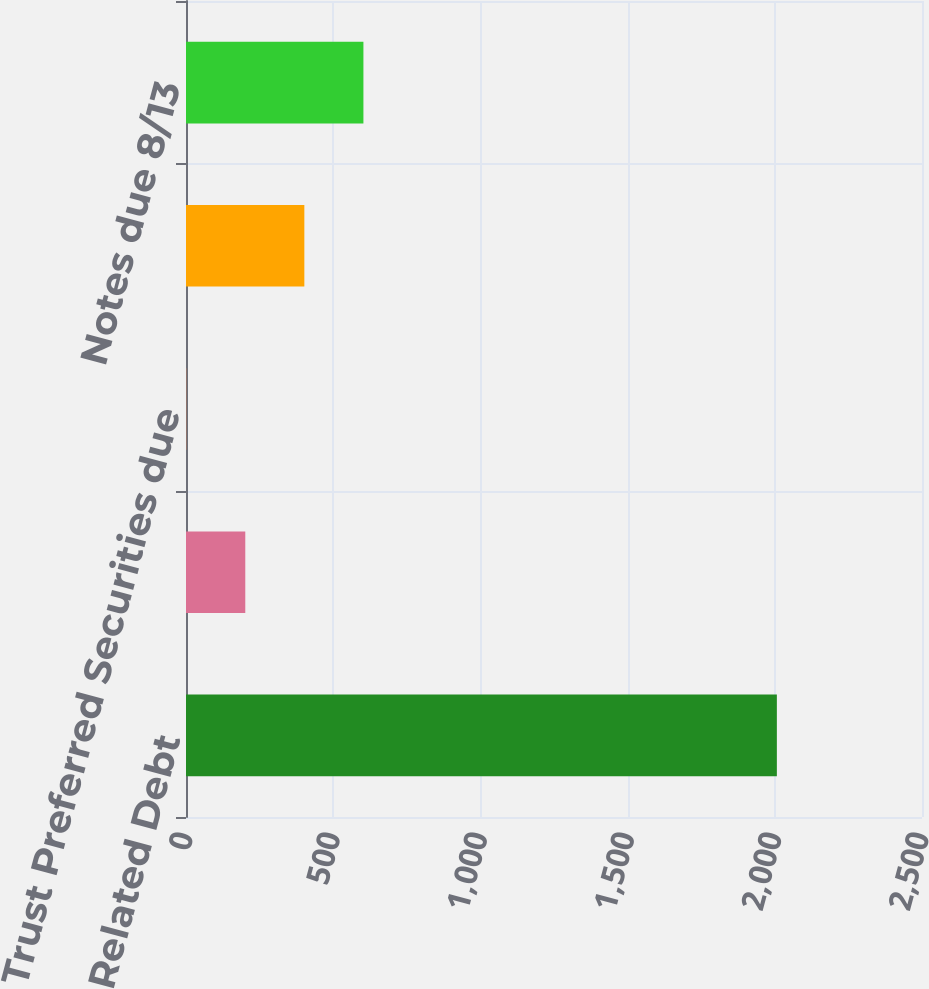Convert chart to OTSL. <chart><loc_0><loc_0><loc_500><loc_500><bar_chart><fcel>Related Debt<fcel>Senior Notes due 12/06 (hedge)<fcel>Trust Preferred Securities due<fcel>Senior Debentures due 8/09<fcel>Notes due 8/13<nl><fcel>2007<fcel>201.37<fcel>0.74<fcel>402<fcel>602.63<nl></chart> 